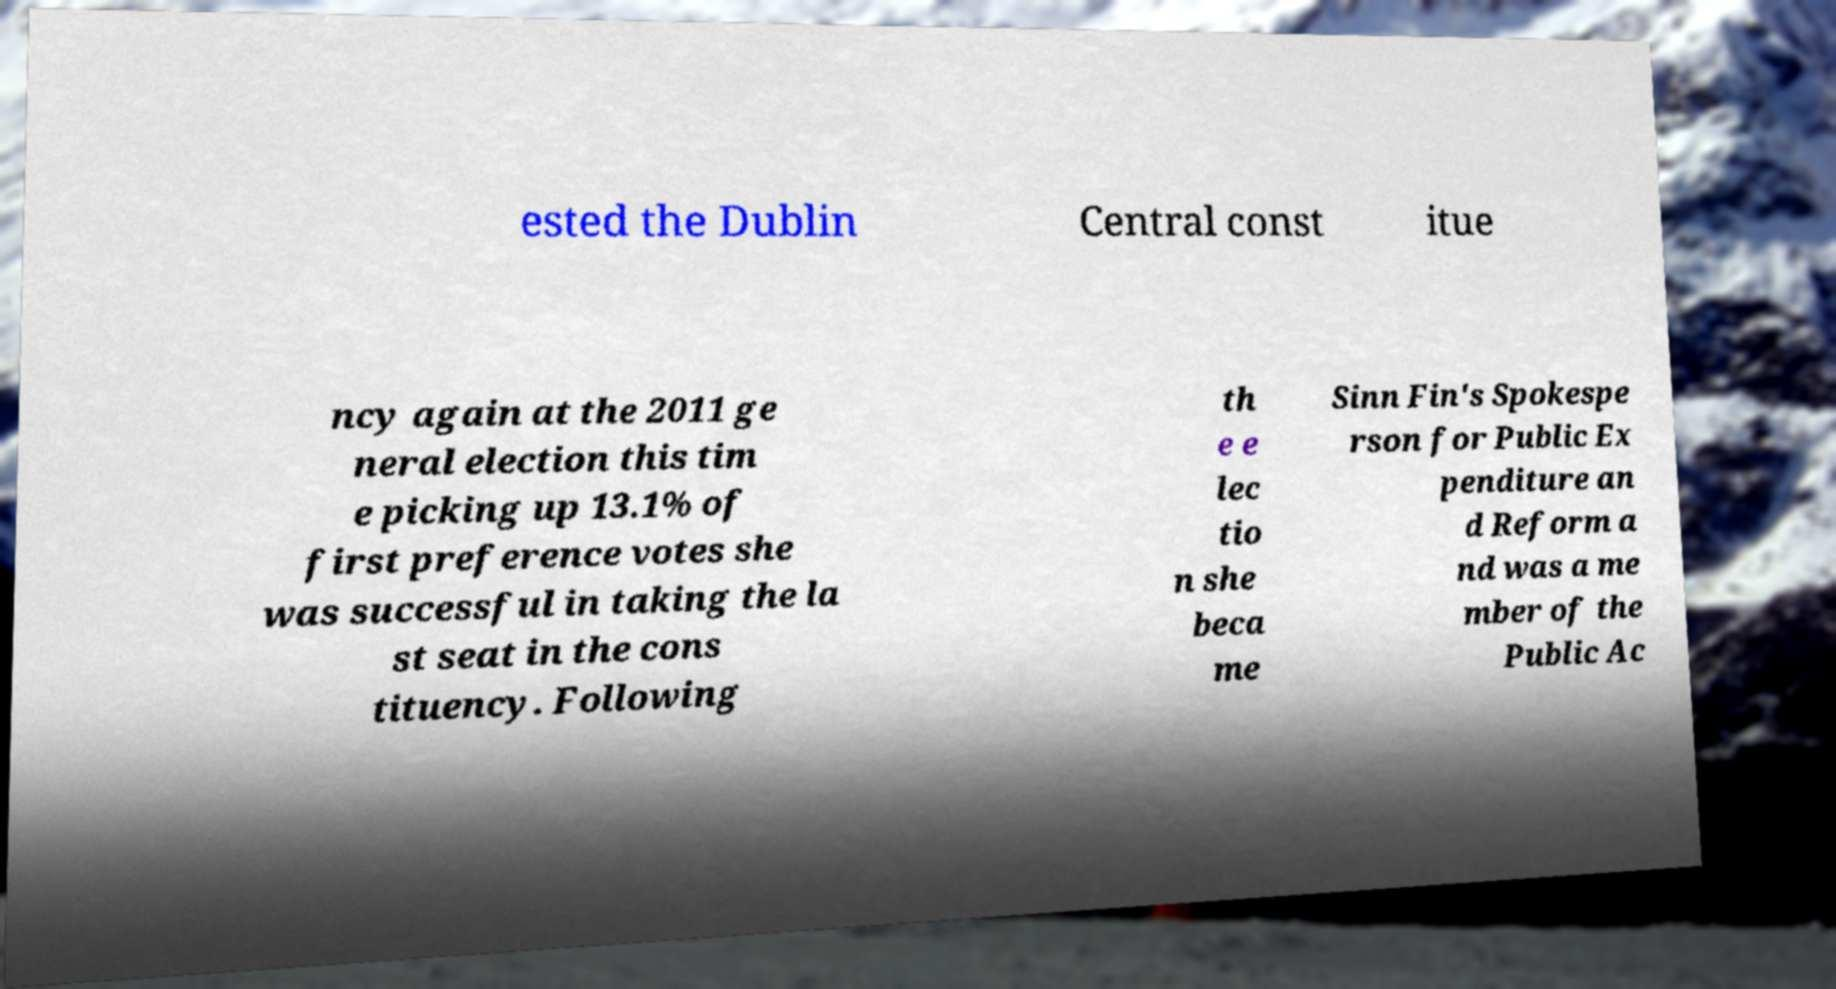Could you extract and type out the text from this image? ested the Dublin Central const itue ncy again at the 2011 ge neral election this tim e picking up 13.1% of first preference votes she was successful in taking the la st seat in the cons tituency. Following th e e lec tio n she beca me Sinn Fin's Spokespe rson for Public Ex penditure an d Reform a nd was a me mber of the Public Ac 